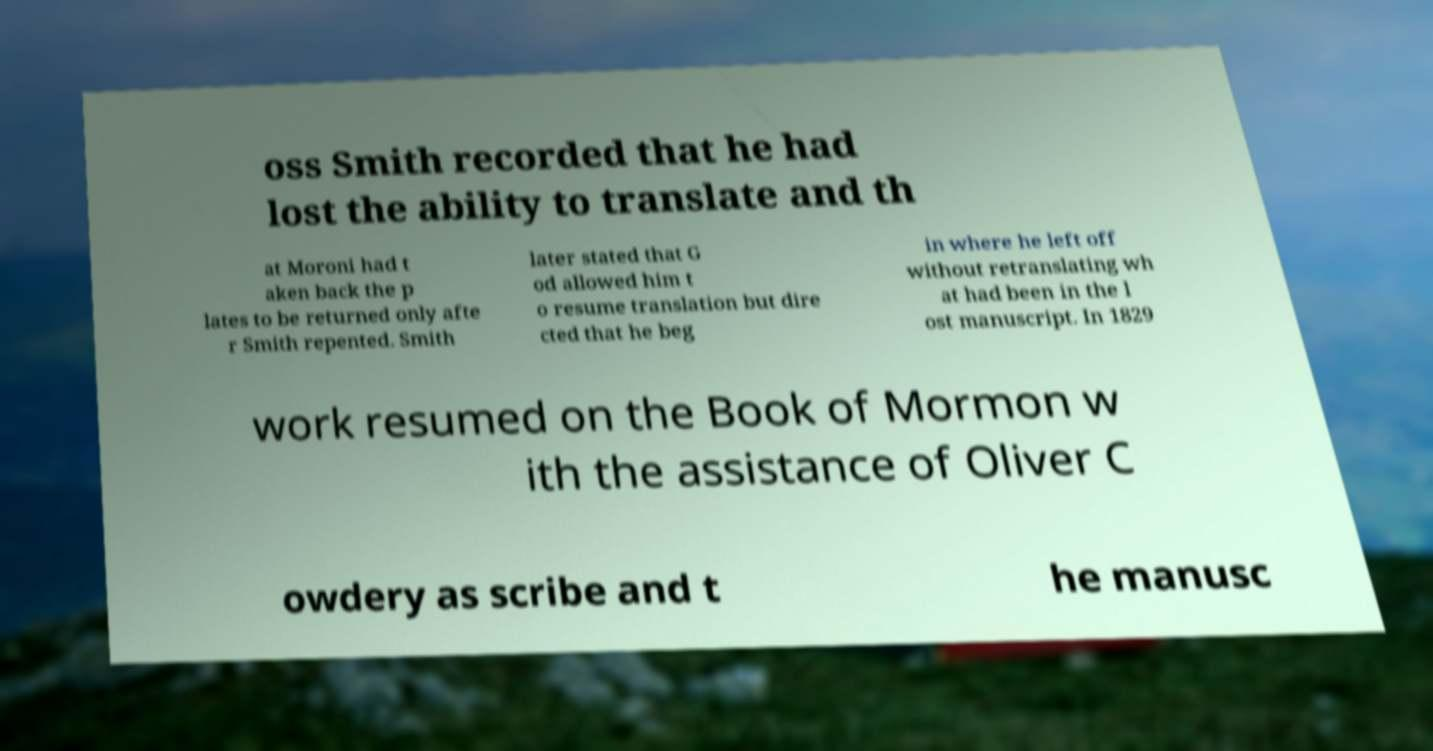I need the written content from this picture converted into text. Can you do that? oss Smith recorded that he had lost the ability to translate and th at Moroni had t aken back the p lates to be returned only afte r Smith repented. Smith later stated that G od allowed him t o resume translation but dire cted that he beg in where he left off without retranslating wh at had been in the l ost manuscript. In 1829 work resumed on the Book of Mormon w ith the assistance of Oliver C owdery as scribe and t he manusc 